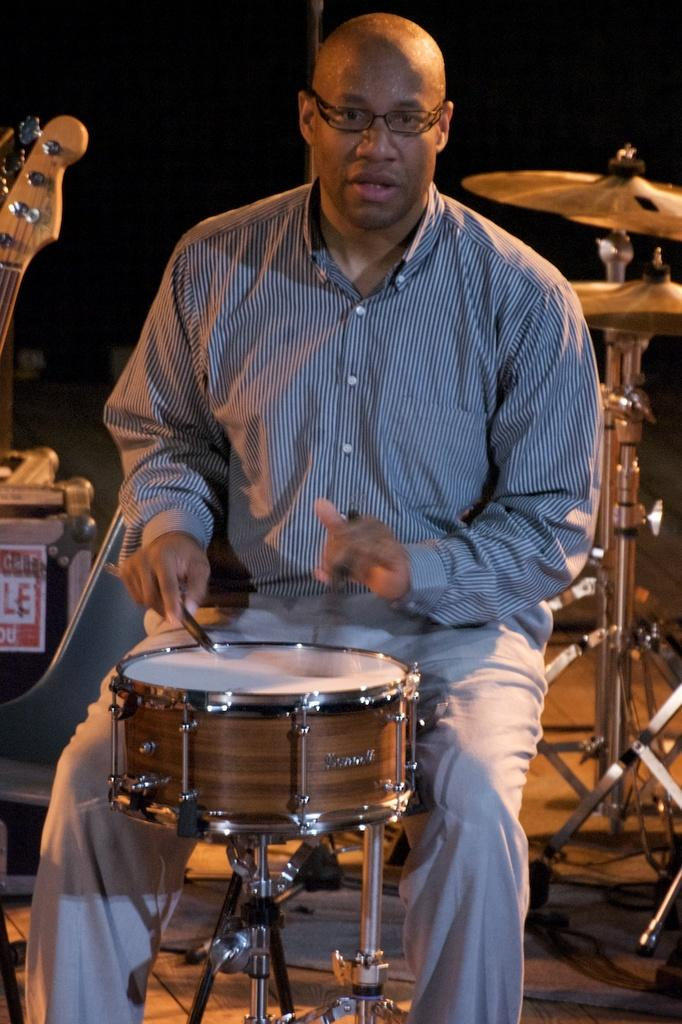Who is the main subject in the image? There is a person in the image. What is the person wearing? The person is wearing specs. What is the person doing in the image? The person is playing a drum. What other musical instruments can be seen in the image? There are multiple musical instruments visible in the image. What type of beam is holding up the roof in the image? There is no mention of a roof or any beams in the image; it features a person playing a drum and other musical instruments. 